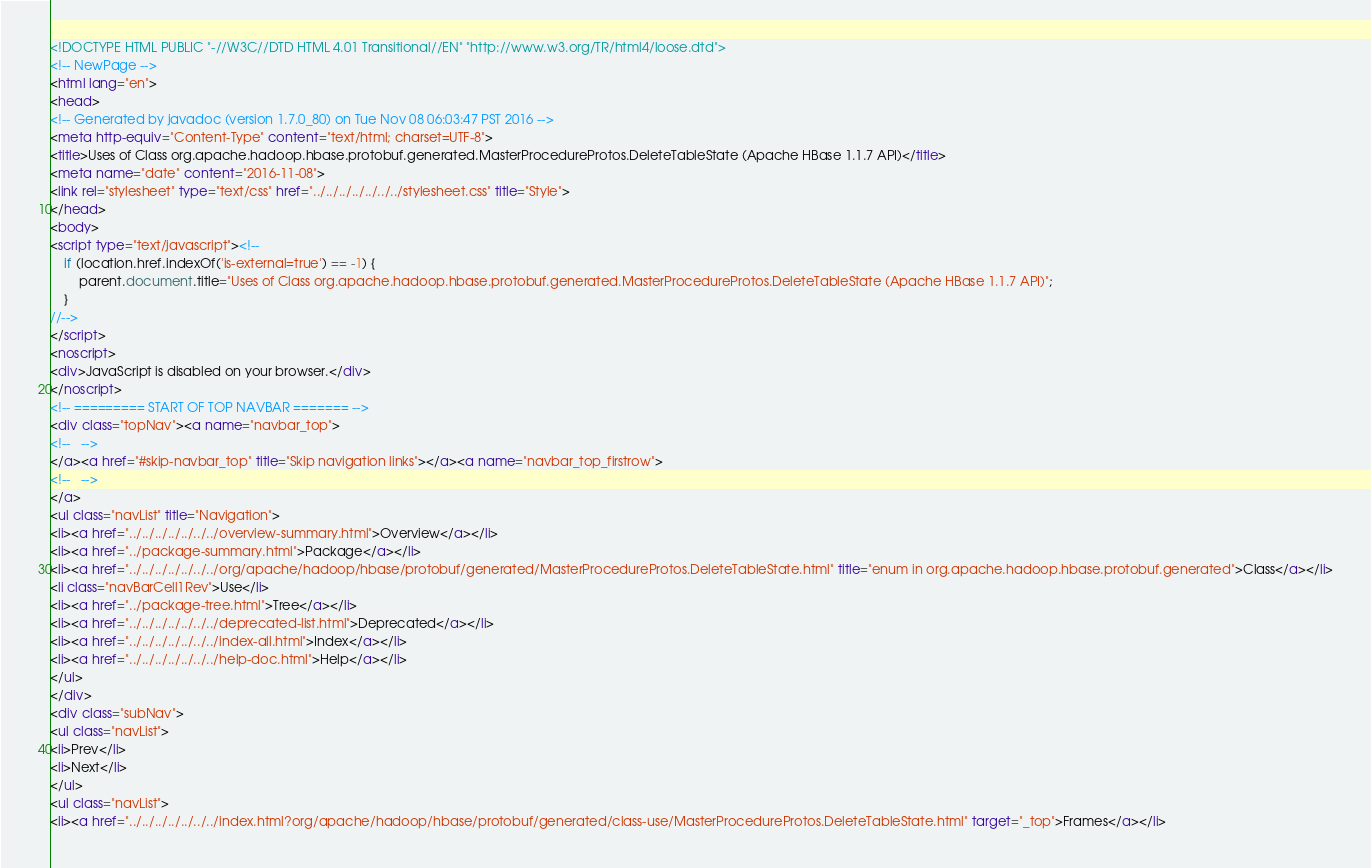Convert code to text. <code><loc_0><loc_0><loc_500><loc_500><_HTML_><!DOCTYPE HTML PUBLIC "-//W3C//DTD HTML 4.01 Transitional//EN" "http://www.w3.org/TR/html4/loose.dtd">
<!-- NewPage -->
<html lang="en">
<head>
<!-- Generated by javadoc (version 1.7.0_80) on Tue Nov 08 06:03:47 PST 2016 -->
<meta http-equiv="Content-Type" content="text/html; charset=UTF-8">
<title>Uses of Class org.apache.hadoop.hbase.protobuf.generated.MasterProcedureProtos.DeleteTableState (Apache HBase 1.1.7 API)</title>
<meta name="date" content="2016-11-08">
<link rel="stylesheet" type="text/css" href="../../../../../../../stylesheet.css" title="Style">
</head>
<body>
<script type="text/javascript"><!--
    if (location.href.indexOf('is-external=true') == -1) {
        parent.document.title="Uses of Class org.apache.hadoop.hbase.protobuf.generated.MasterProcedureProtos.DeleteTableState (Apache HBase 1.1.7 API)";
    }
//-->
</script>
<noscript>
<div>JavaScript is disabled on your browser.</div>
</noscript>
<!-- ========= START OF TOP NAVBAR ======= -->
<div class="topNav"><a name="navbar_top">
<!--   -->
</a><a href="#skip-navbar_top" title="Skip navigation links"></a><a name="navbar_top_firstrow">
<!--   -->
</a>
<ul class="navList" title="Navigation">
<li><a href="../../../../../../../overview-summary.html">Overview</a></li>
<li><a href="../package-summary.html">Package</a></li>
<li><a href="../../../../../../../org/apache/hadoop/hbase/protobuf/generated/MasterProcedureProtos.DeleteTableState.html" title="enum in org.apache.hadoop.hbase.protobuf.generated">Class</a></li>
<li class="navBarCell1Rev">Use</li>
<li><a href="../package-tree.html">Tree</a></li>
<li><a href="../../../../../../../deprecated-list.html">Deprecated</a></li>
<li><a href="../../../../../../../index-all.html">Index</a></li>
<li><a href="../../../../../../../help-doc.html">Help</a></li>
</ul>
</div>
<div class="subNav">
<ul class="navList">
<li>Prev</li>
<li>Next</li>
</ul>
<ul class="navList">
<li><a href="../../../../../../../index.html?org/apache/hadoop/hbase/protobuf/generated/class-use/MasterProcedureProtos.DeleteTableState.html" target="_top">Frames</a></li></code> 